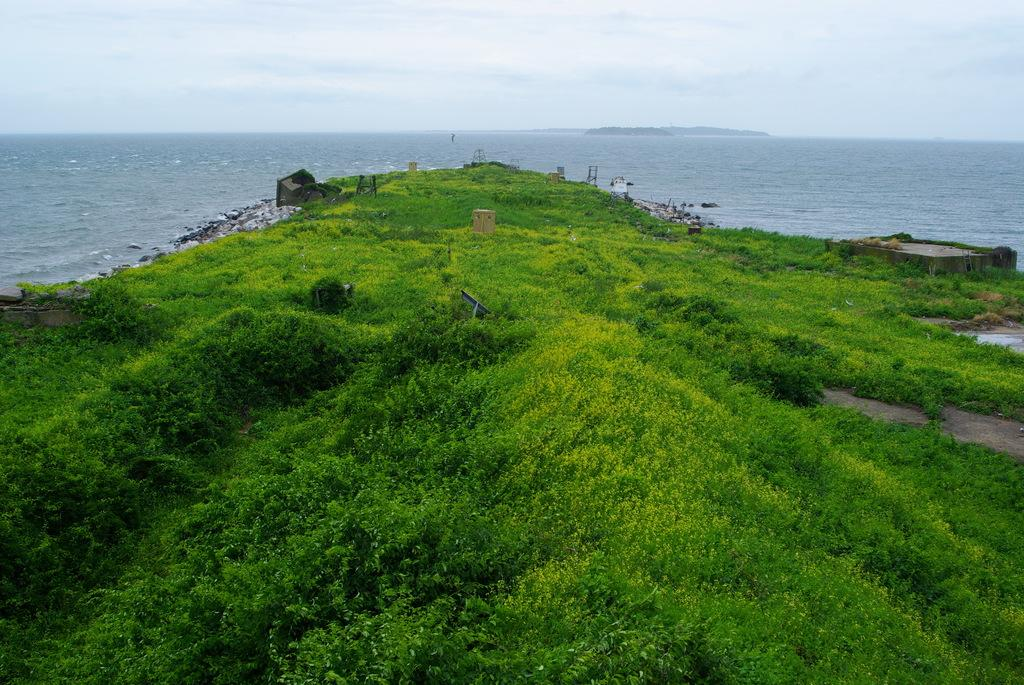What type of terrain is visible in the image? There is a land with green grass in the image. What natural feature is located behind the land? There is an ocean behind the land. What part of the sky is visible in the image? The sky is visible in the image. What can be seen in the sky besides the sky itself? Clouds are present in the sky. How many letters can be seen floating in the ocean in the image? There are no letters visible in the image, as it features a land with green grass, an ocean, and a sky with clouds. Can you describe the behavior of the wren in the image? There is no wren present in the image; it only features a land with green grass, an ocean, and a sky with clouds. 